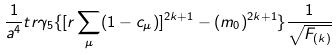<formula> <loc_0><loc_0><loc_500><loc_500>\frac { 1 } { a ^ { 4 } } t r \gamma _ { 5 } \{ [ r \sum _ { \mu } ( 1 - c _ { \mu } ) ] ^ { 2 k + 1 } - ( m _ { 0 } ) ^ { 2 k + 1 } \} \frac { 1 } { \sqrt { F _ { ( k ) } } }</formula> 